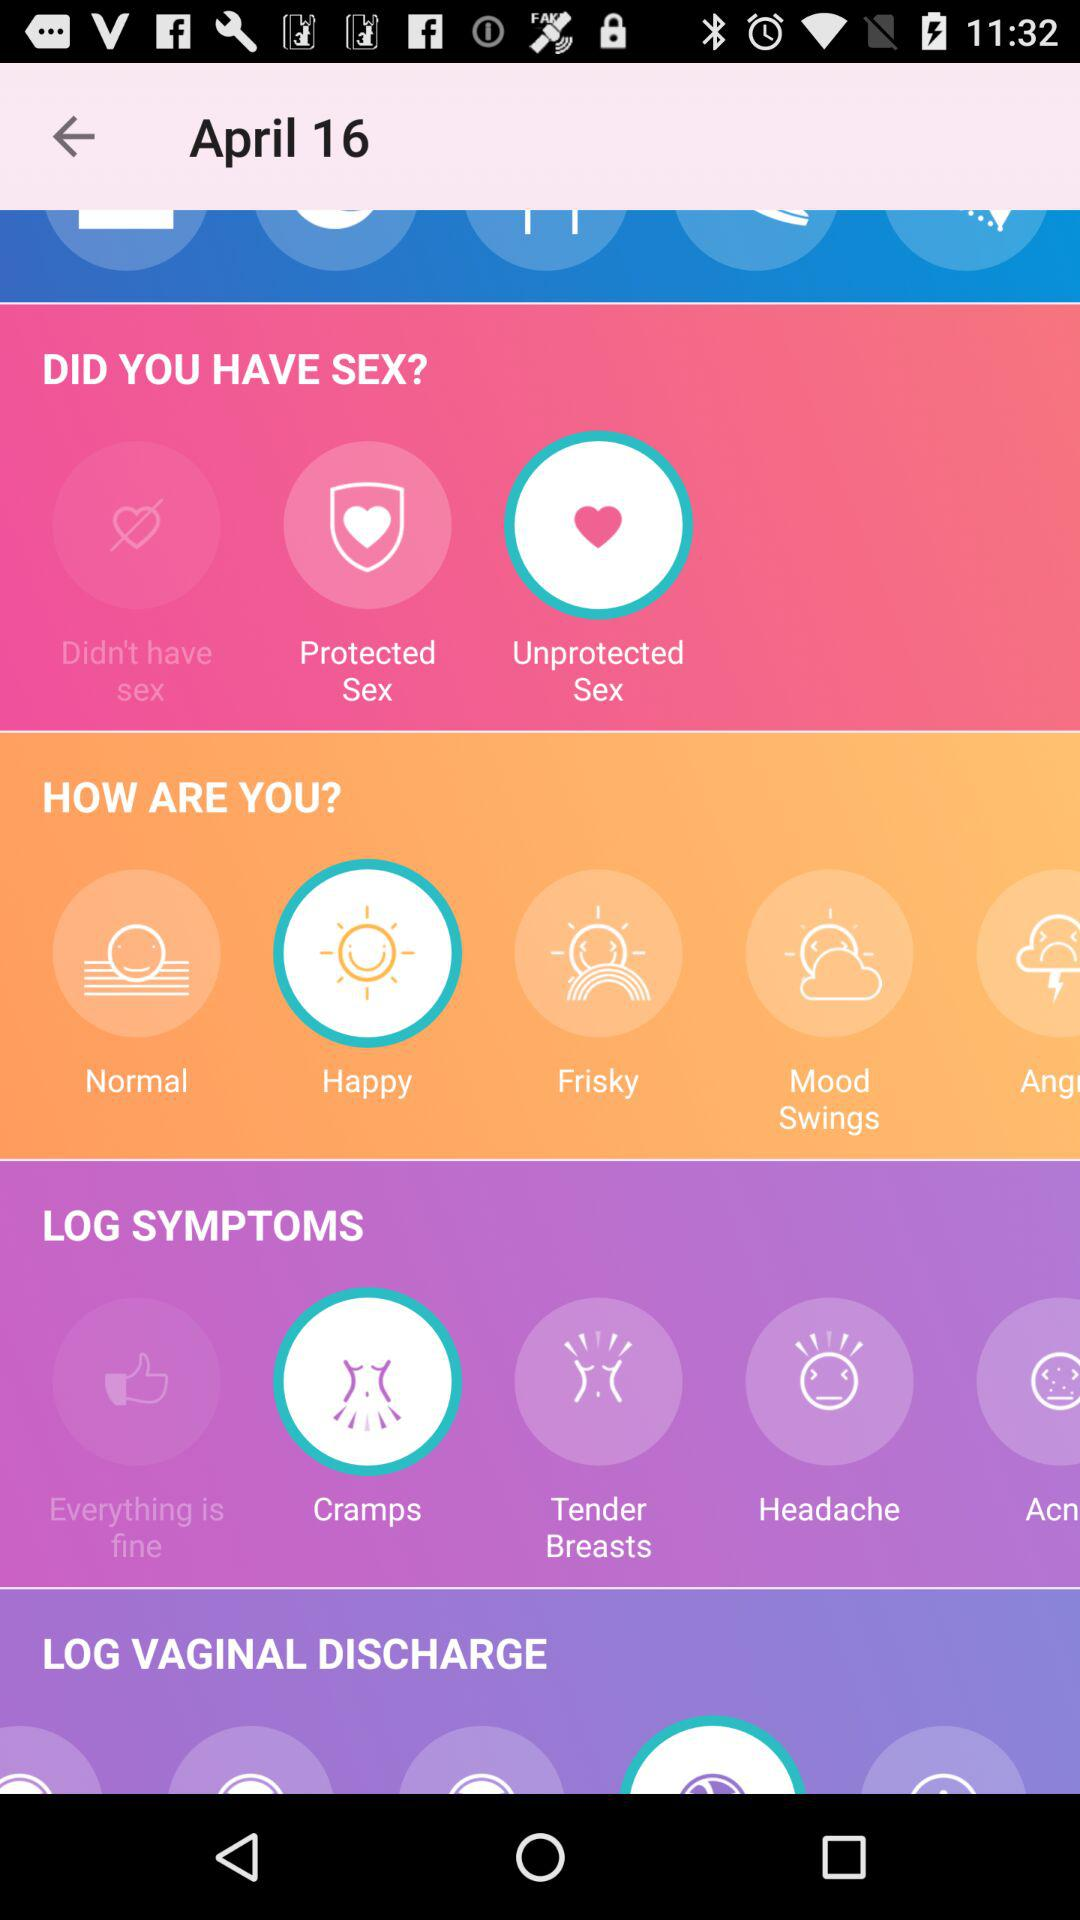What option is selected in "LOG SYMPTOMS"? The selected option is "Cramps". 